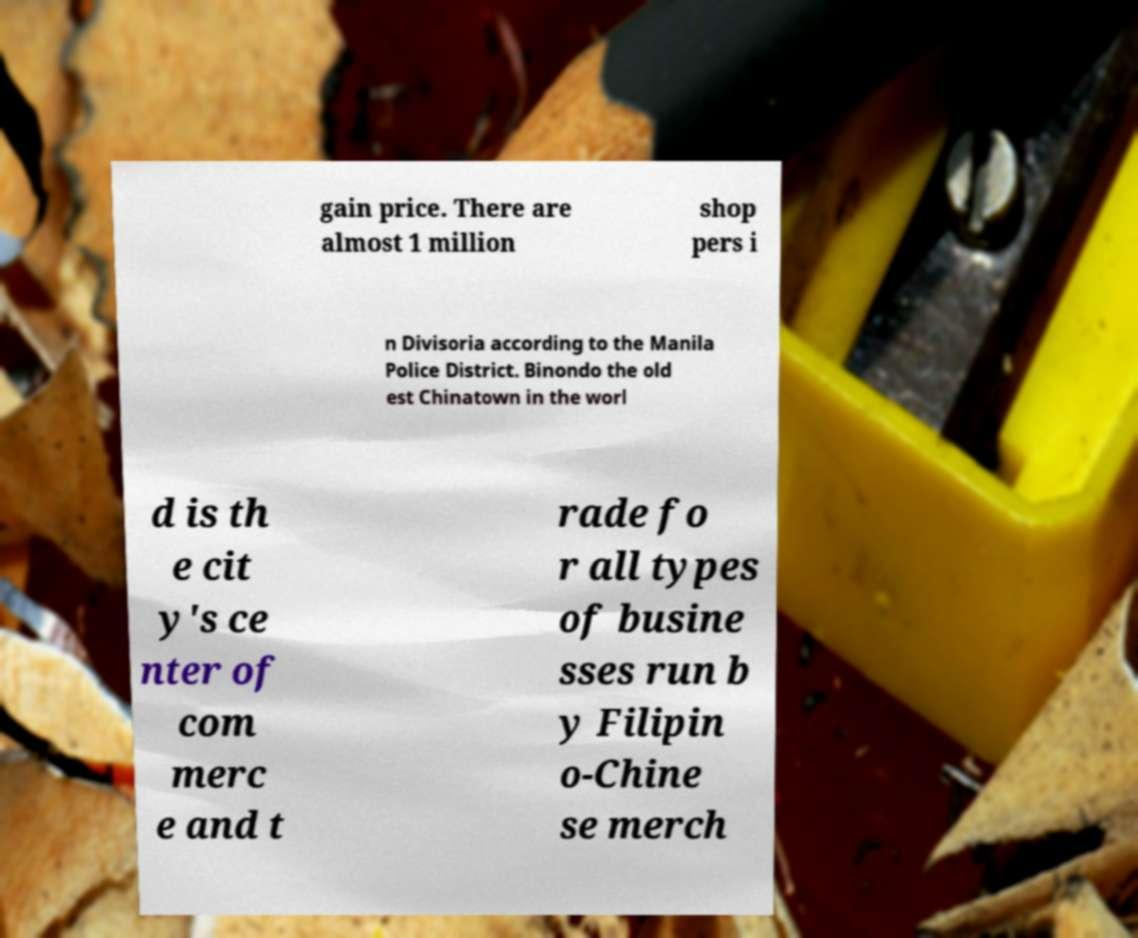Could you assist in decoding the text presented in this image and type it out clearly? gain price. There are almost 1 million shop pers i n Divisoria according to the Manila Police District. Binondo the old est Chinatown in the worl d is th e cit y's ce nter of com merc e and t rade fo r all types of busine sses run b y Filipin o-Chine se merch 